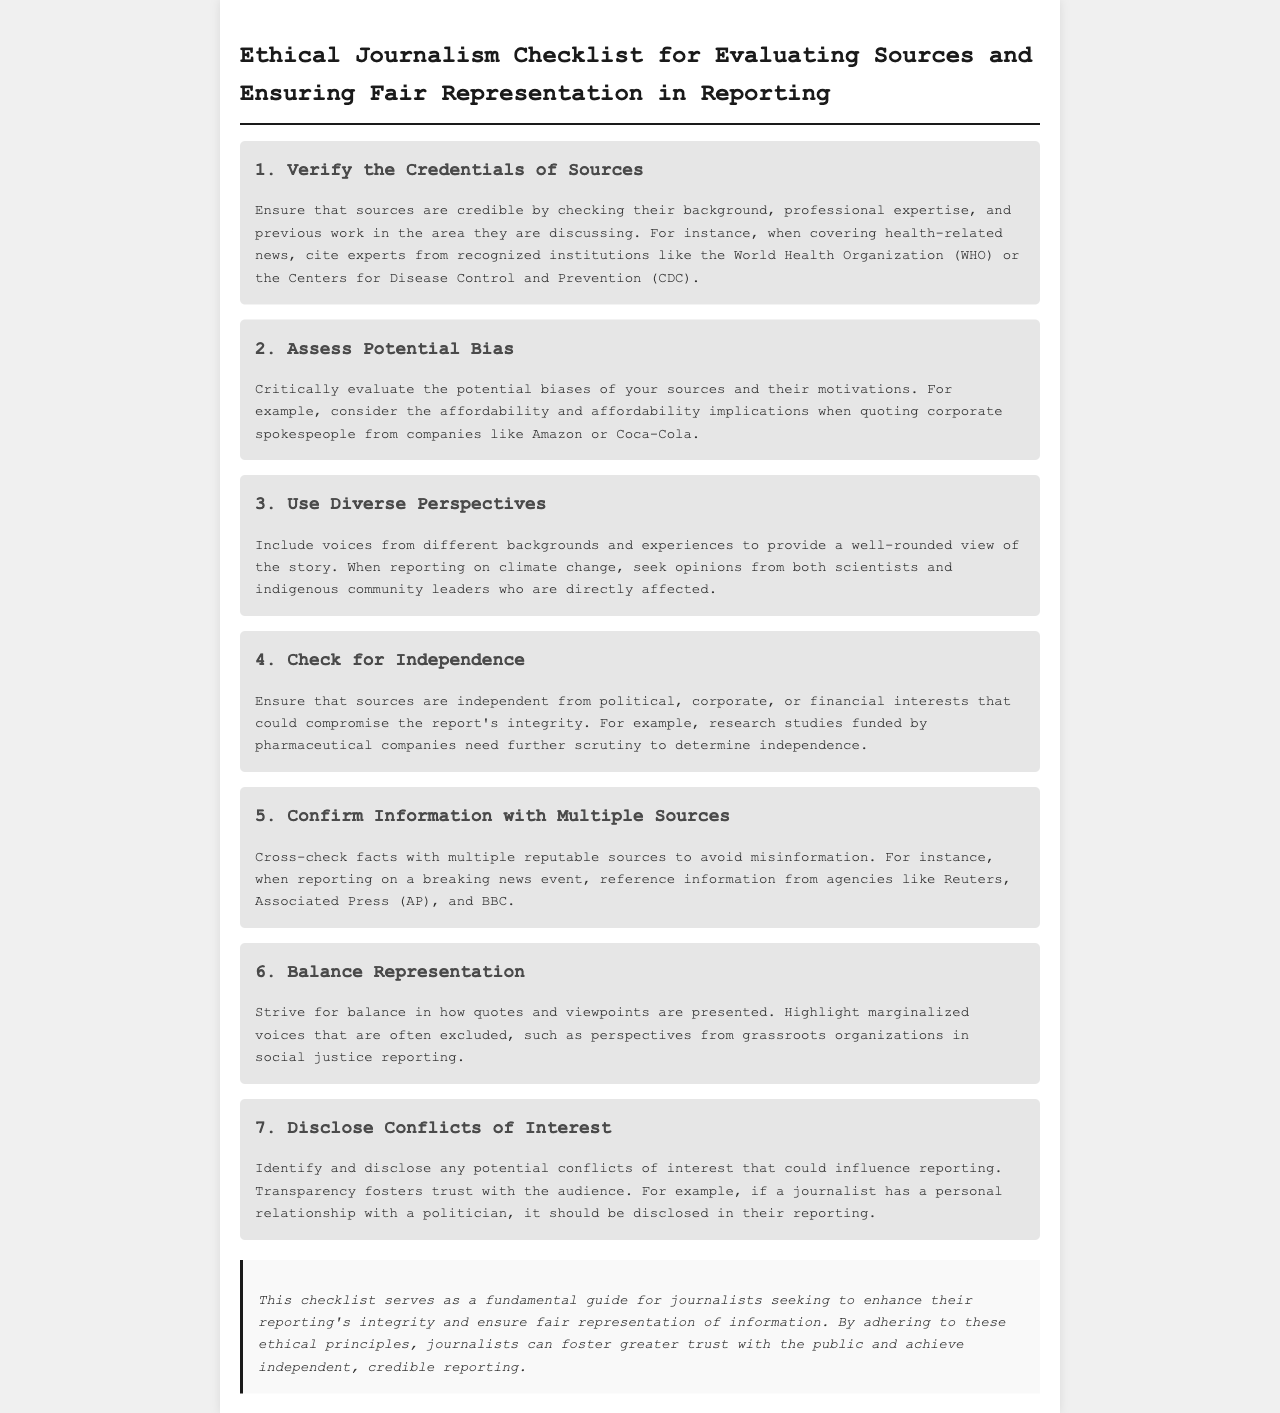what is the title of the document? The title of the document is provided in the header section and indicates the subject matter it addresses.
Answer: Ethical Journalism Checklist for Evaluating Sources and Ensuring Fair Representation in Reporting how many checklist items are included? The number of checklist items can be found by counting the sections outlined in the document.
Answer: 7 which organization is recommended for credible health sources? The document mentions specific institutions regarded as credible for health-related information.
Answer: World Health Organization (WHO) what is a key aspect to assess in regard to sources? The document emphasizes the importance of evaluating certain characteristics of sources to ensure integrity in reporting.
Answer: Potential Bias which type of voices should be included in reporting? The document suggests that reporters should seek a variety of opinions to enrich their stories.
Answer: Diverse Perspectives how should conflicts of interest be handled? The manual advises on the transparency of potential conflicts that might affect reporting.
Answer: Disclose Conflicts of Interest what is one reason for confirming information with multiple sources? The document highlights why it is crucial to verify facts before reporting them.
Answer: Avoid misinformation 